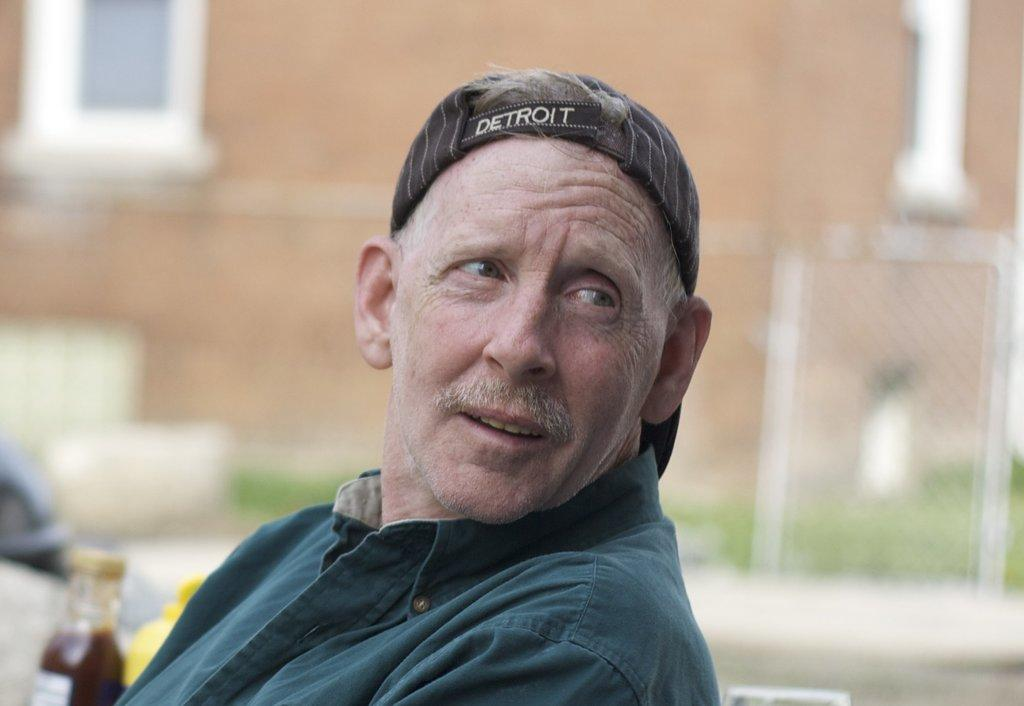Who is the main subject in the image? There is a man in the center of the image. What is the man wearing on his head? The man is wearing a cap. What can be seen in the background of the image? There is a building and a mesh in the background of the image. What type of drawer is visible in the image? There is no drawer present in the image. What time of day is it in the image? The time of day cannot be determined from the image. 